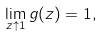<formula> <loc_0><loc_0><loc_500><loc_500>\lim _ { z \uparrow 1 } g ( z ) = 1 ,</formula> 